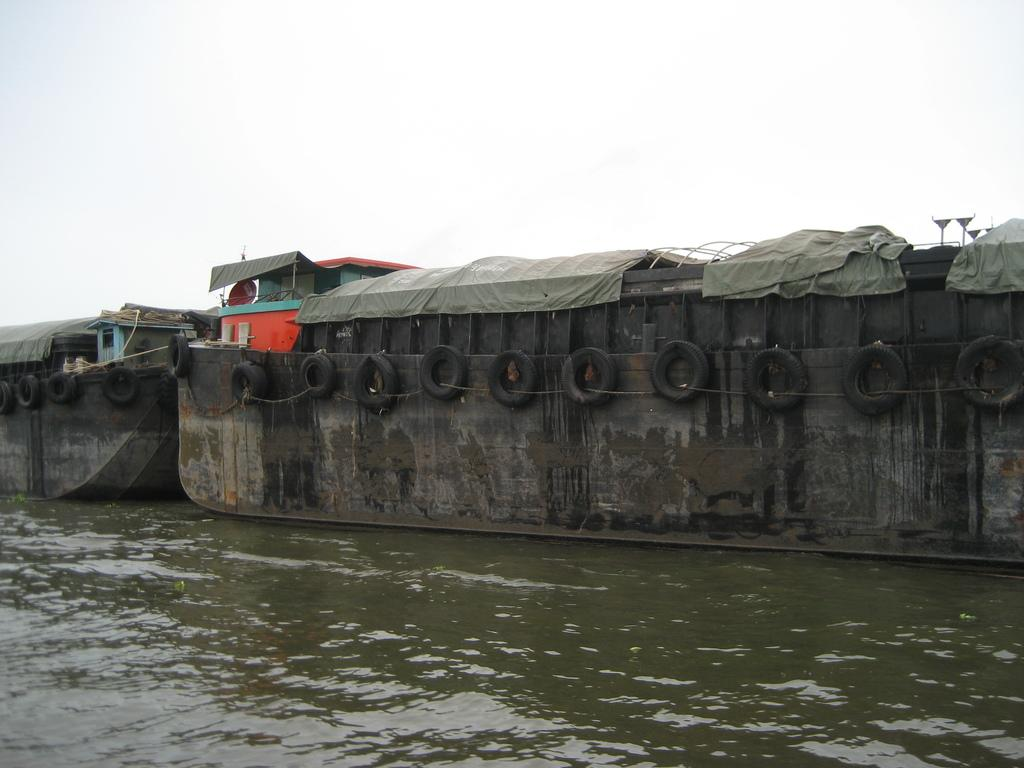What can be seen in the image related to water transportation? There are two boats in the image. Where are the boats located? The boats are moving on a lake. What structures are present above the boats? There are tents above the boats. What is hanging from the tents? Tires are hanging from the tents. What part of the natural environment is visible in the image? The sky is visible in the image. What type of nerve can be seen stimulating the thumb in the image? There is no nerve or thumb present in the image; it features two boats moving on a lake with tents and tires hanging from them. 